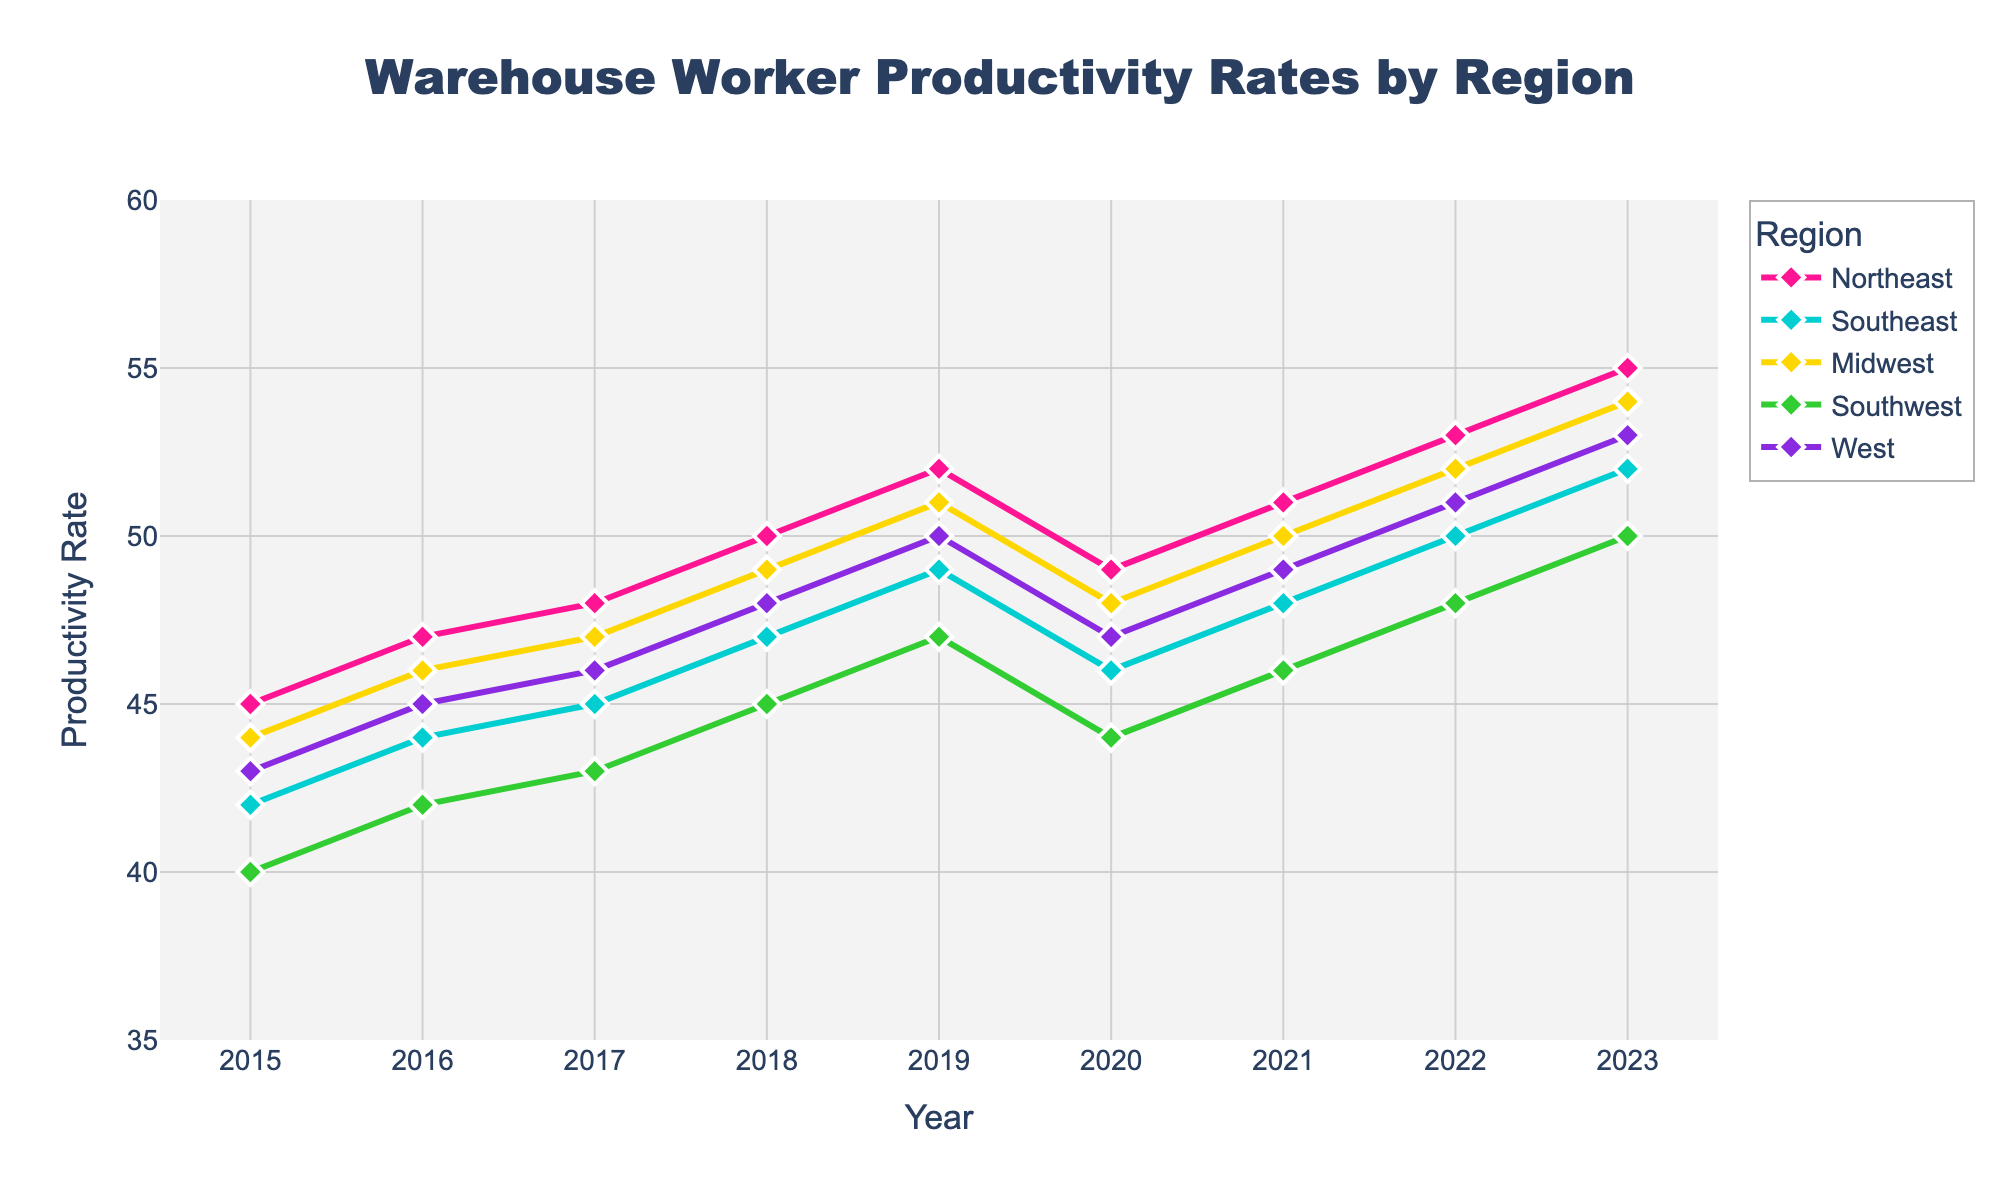what was the productivity rate in the Northeast in 2019? Locate the line representing the Northeast (magenta line) and find the data point above 2019. The productivity rate is marked at 52.
Answer: 52 Which region had the highest productivity rate in 2023? Look at the data points above 2023 for all lines. The highest data point is on the magenta line (Northeast) at 55.
Answer: Northeast How did the productivity rate of the Midwest change between 2018 and 2020? Find the blue line representing the Midwest and locate the points above 2018 (49) and 2020 (48). The rate decreased by 1 point.
Answer: Decreased by 1 What is the average productivity rate of the Southwest in the years 2019, 2020, and 2021? Locate the green line for Southwest and find the points above 2019 (47), 2020 (44), and 2021 (46). Calculate the average: (47+44+46)/3 = 45.67.
Answer: 45.67 Which region showed the most consistent increase in productivity rates from 2015 to 2023? Examine the slopes of all the lines from left to right. The purple line (West) appears consistently upward without drops.
Answer: West In which year did the West region first surpass a productivity rate of 50? Locate the purple line and track it to see where it crosses the 50 mark. It crosses over 50 in 2022.
Answer: 2022 How does the productivity rate of the Southeast in 2023 compare to that of the Southwest in the same year? Locate the lines for Southeast (cyan) and Southwest (green) above 2023. Southeast is at 52, and Southwest is at 50. Southeast is 2 points higher.
Answer: Southeast is 2 points higher What is the sum of productivity rates for all regions in 2018? Find the values for all regions in 2018: Northeast (50), Southeast (47), Midwest (49), Southwest (45), and West (48). Sum them up: 50+47+49+45+48 = 239.
Answer: 239 Which region experienced a decrease in productivity between 2019 and 2020? Compare the values for each line between 2019 and 2020. Both the Northeast (52->49), Southeast (49->46), and West (50->47) showed a decrease.
Answer: Northeast, Southeast, West What is the range of productivity rates across all regions in 2020? Find the highest and lowest points for 2020: Highest (Northeast at 49), lowest (Southwest at 44). Calculate the range: 49 - 44 = 5.
Answer: 5 